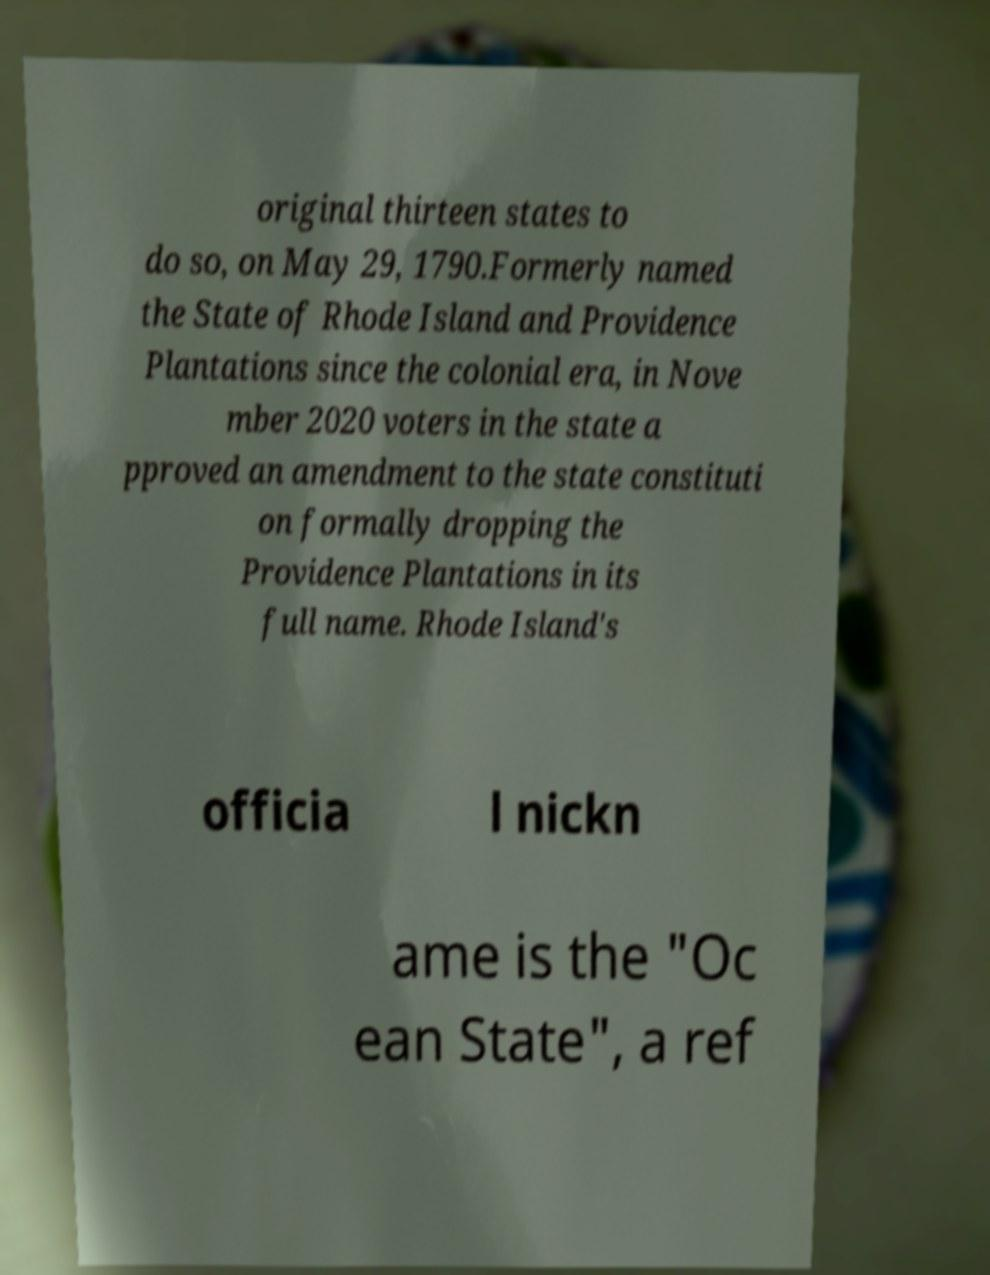There's text embedded in this image that I need extracted. Can you transcribe it verbatim? original thirteen states to do so, on May 29, 1790.Formerly named the State of Rhode Island and Providence Plantations since the colonial era, in Nove mber 2020 voters in the state a pproved an amendment to the state constituti on formally dropping the Providence Plantations in its full name. Rhode Island's officia l nickn ame is the "Oc ean State", a ref 